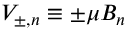Convert formula to latex. <formula><loc_0><loc_0><loc_500><loc_500>V _ { \pm , n } \equiv \pm \mu B _ { n }</formula> 